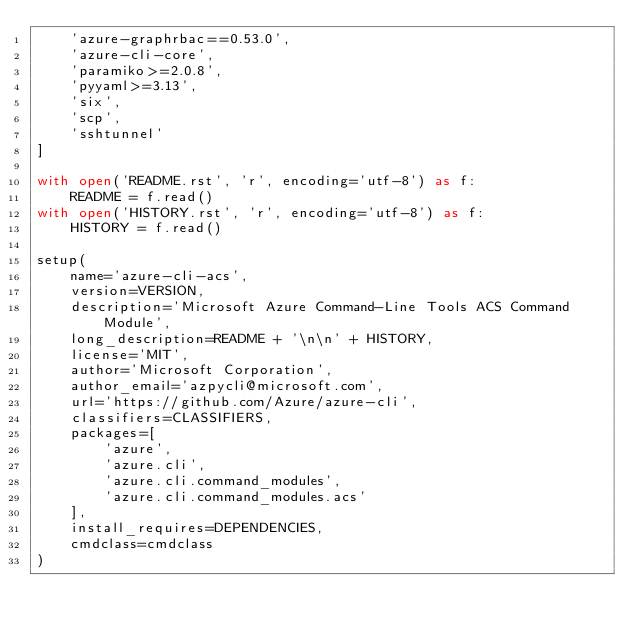<code> <loc_0><loc_0><loc_500><loc_500><_Python_>    'azure-graphrbac==0.53.0',
    'azure-cli-core',
    'paramiko>=2.0.8',
    'pyyaml>=3.13',
    'six',
    'scp',
    'sshtunnel'
]

with open('README.rst', 'r', encoding='utf-8') as f:
    README = f.read()
with open('HISTORY.rst', 'r', encoding='utf-8') as f:
    HISTORY = f.read()

setup(
    name='azure-cli-acs',
    version=VERSION,
    description='Microsoft Azure Command-Line Tools ACS Command Module',
    long_description=README + '\n\n' + HISTORY,
    license='MIT',
    author='Microsoft Corporation',
    author_email='azpycli@microsoft.com',
    url='https://github.com/Azure/azure-cli',
    classifiers=CLASSIFIERS,
    packages=[
        'azure',
        'azure.cli',
        'azure.cli.command_modules',
        'azure.cli.command_modules.acs'
    ],
    install_requires=DEPENDENCIES,
    cmdclass=cmdclass
)
</code> 